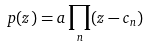<formula> <loc_0><loc_0><loc_500><loc_500>p ( z ) = a \prod _ { n } ( z - c _ { n } )</formula> 